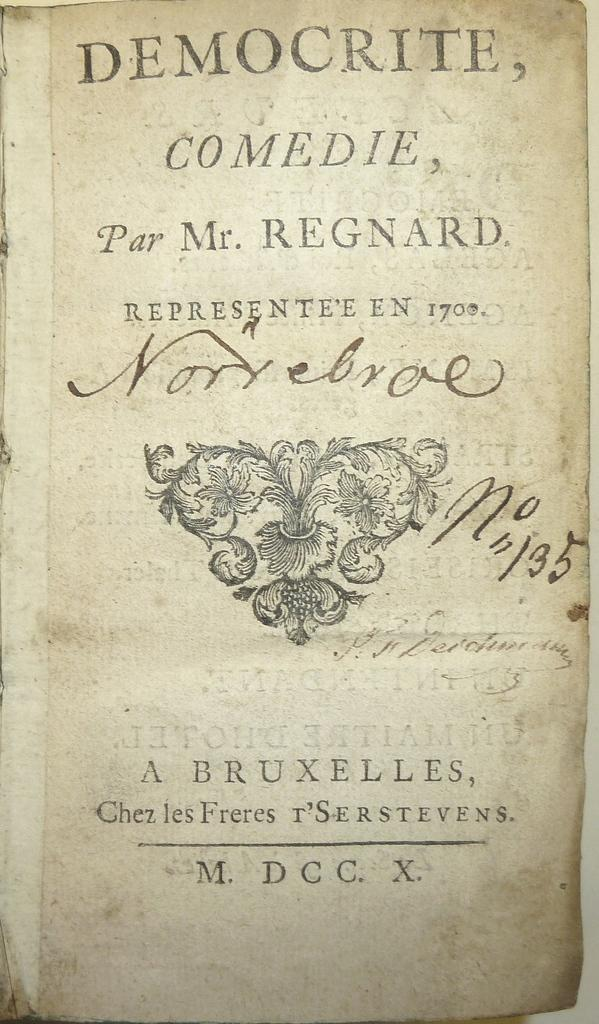Provide a one-sentence caption for the provided image. An exceptionally old copy of Democrite, Comedie, Par Mr. Regnard. 